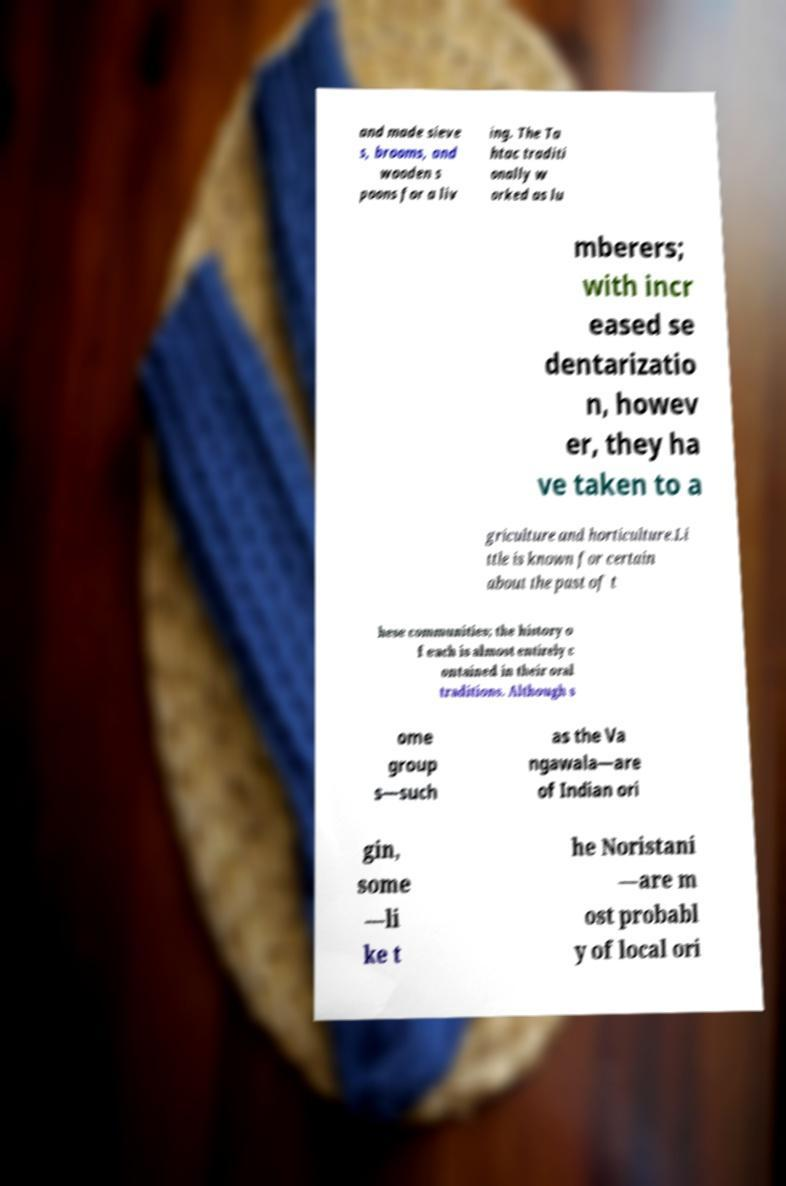Please identify and transcribe the text found in this image. and made sieve s, brooms, and wooden s poons for a liv ing. The Ta htac traditi onally w orked as lu mberers; with incr eased se dentarizatio n, howev er, they ha ve taken to a griculture and horticulture.Li ttle is known for certain about the past of t hese communities; the history o f each is almost entirely c ontained in their oral traditions. Although s ome group s—such as the Va ngawala—are of Indian ori gin, some —li ke t he Noristani —are m ost probabl y of local ori 